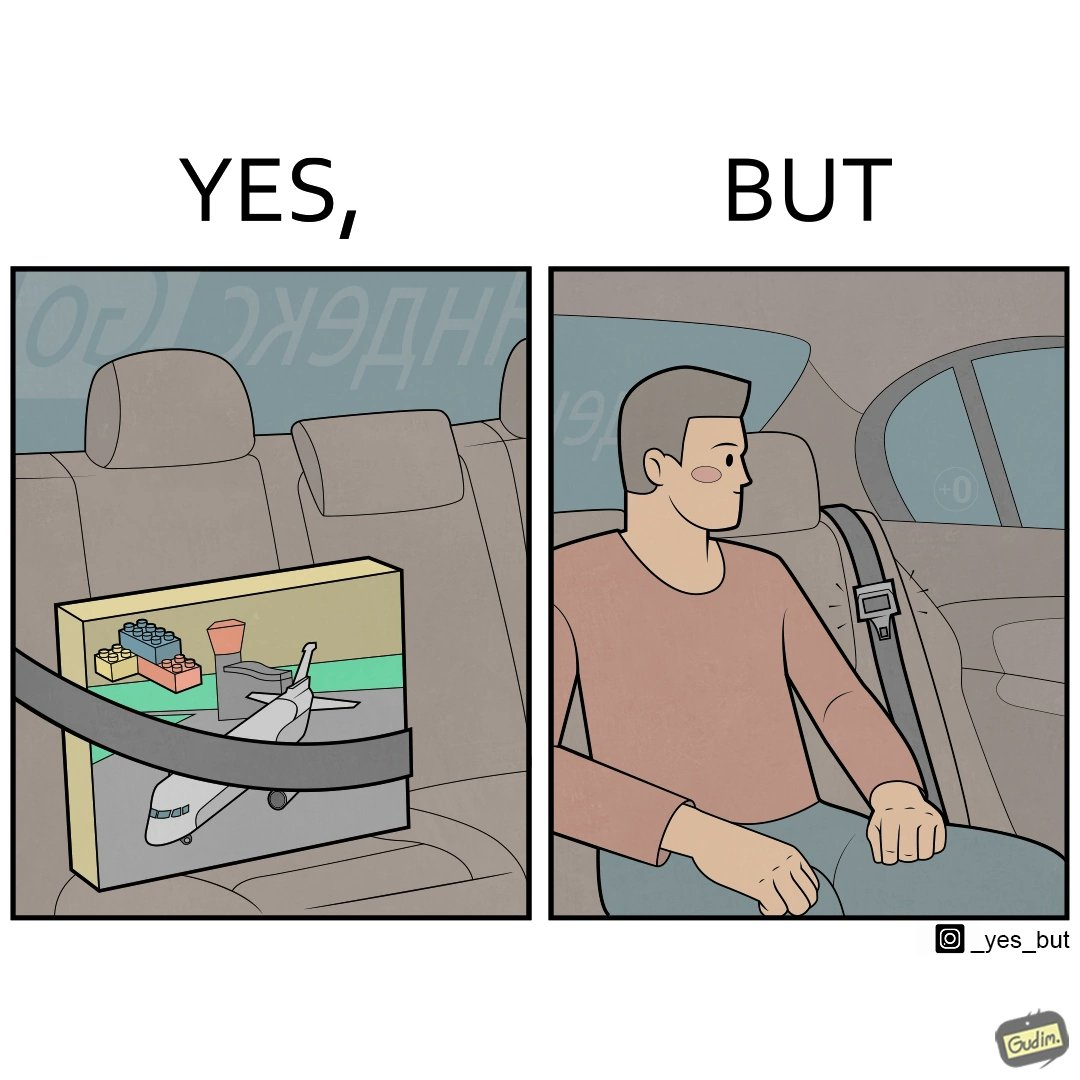What makes this image funny or satirical? The image is ironical, as an inanimate box of building blocks has been secured by the seatbelt in the backseat of a car, while a person sitting in the backseat is not wearing the seatbelt, while the person would actually need the seatbelt in case there is an accident. 